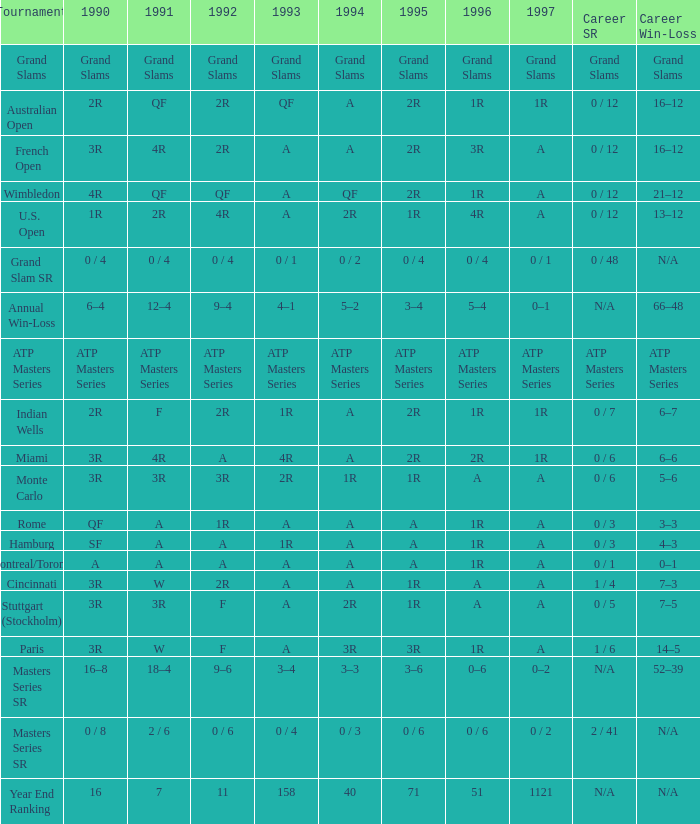When the tournament is "miami," what is the significance of 1995? 2R. 